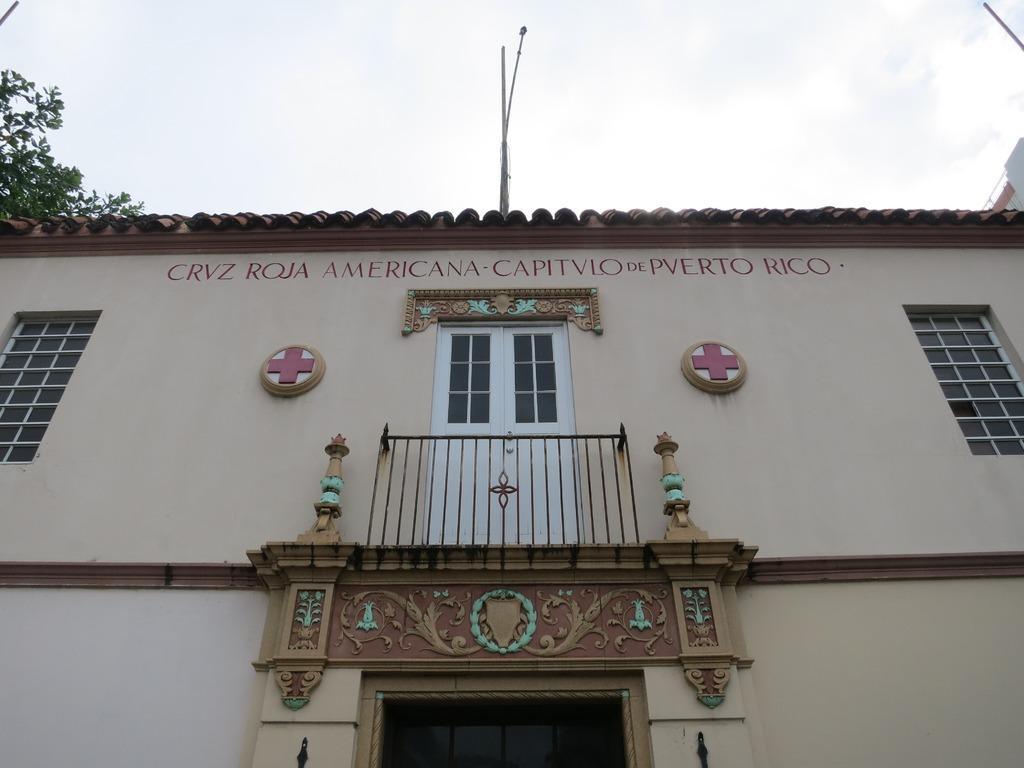Can you describe this image briefly? Here in this picture we can see a building present and on that we can see windows and a door present near the balcony and we can see light posts on the building and we can also see trees over there. 